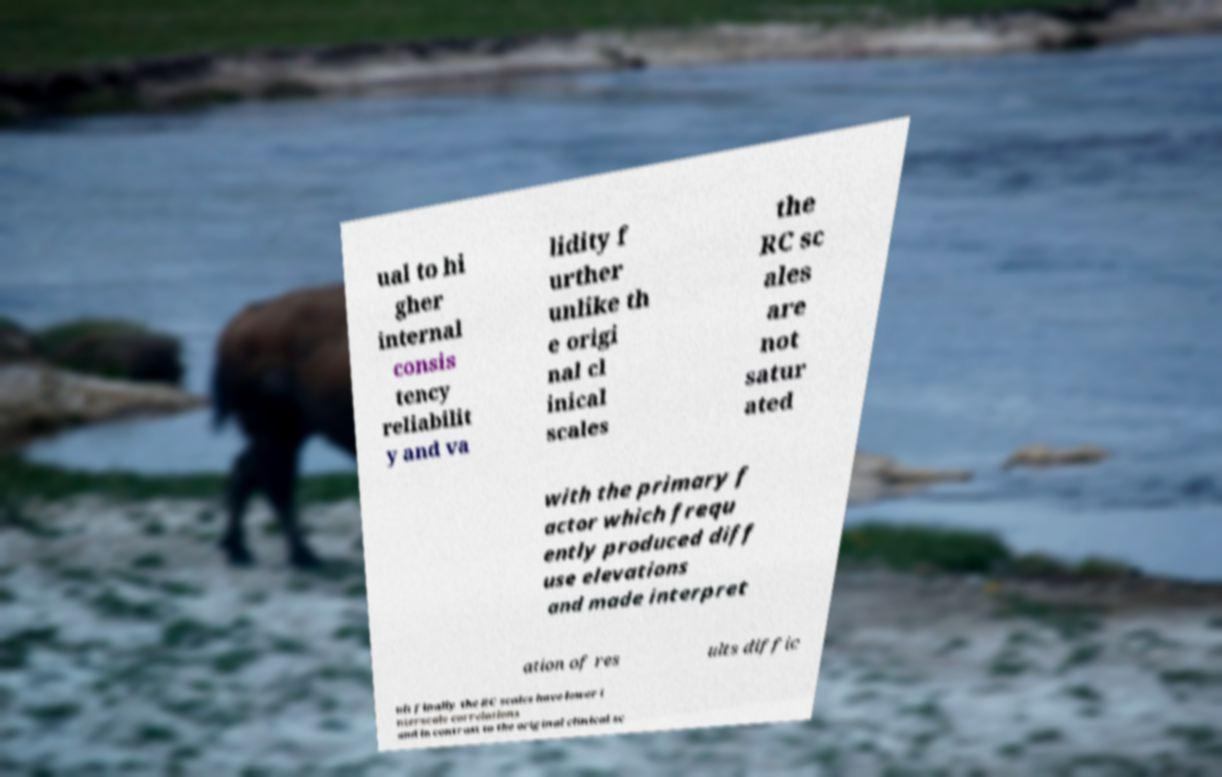For documentation purposes, I need the text within this image transcribed. Could you provide that? ual to hi gher internal consis tency reliabilit y and va lidity f urther unlike th e origi nal cl inical scales the RC sc ales are not satur ated with the primary f actor which frequ ently produced diff use elevations and made interpret ation of res ults diffic ult finally the RC scales have lower i nterscale correlations and in contrast to the original clinical sc 